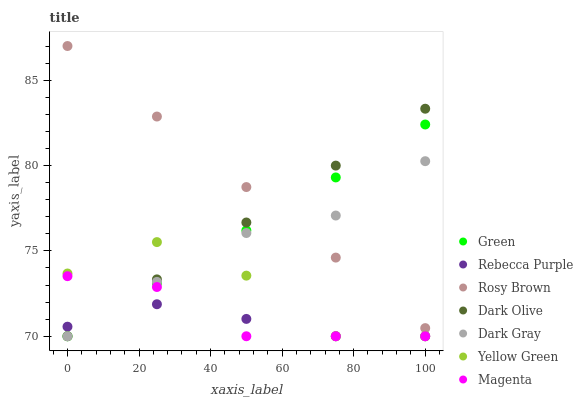Does Rebecca Purple have the minimum area under the curve?
Answer yes or no. Yes. Does Rosy Brown have the maximum area under the curve?
Answer yes or no. Yes. Does Yellow Green have the minimum area under the curve?
Answer yes or no. No. Does Yellow Green have the maximum area under the curve?
Answer yes or no. No. Is Green the smoothest?
Answer yes or no. Yes. Is Yellow Green the roughest?
Answer yes or no. Yes. Is Dark Olive the smoothest?
Answer yes or no. No. Is Dark Olive the roughest?
Answer yes or no. No. Does Yellow Green have the lowest value?
Answer yes or no. Yes. Does Rosy Brown have the highest value?
Answer yes or no. Yes. Does Yellow Green have the highest value?
Answer yes or no. No. Is Magenta less than Rosy Brown?
Answer yes or no. Yes. Is Rosy Brown greater than Rebecca Purple?
Answer yes or no. Yes. Does Yellow Green intersect Magenta?
Answer yes or no. Yes. Is Yellow Green less than Magenta?
Answer yes or no. No. Is Yellow Green greater than Magenta?
Answer yes or no. No. Does Magenta intersect Rosy Brown?
Answer yes or no. No. 